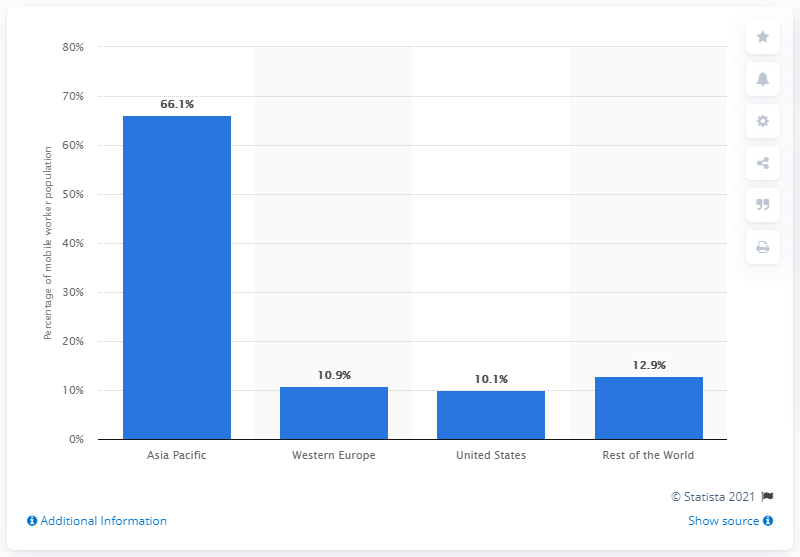Indicate a few pertinent items in this graphic. Approximately 10.1% of mobile workers worldwide were located in the United States in 2013. 